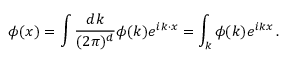Convert formula to latex. <formula><loc_0><loc_0><loc_500><loc_500>\phi ( x ) = \int { \frac { d k } { ( 2 \pi ) ^ { d } } } \phi ( k ) e ^ { i k \cdot x } = \int _ { k } \phi ( k ) e ^ { i k x } \, .</formula> 